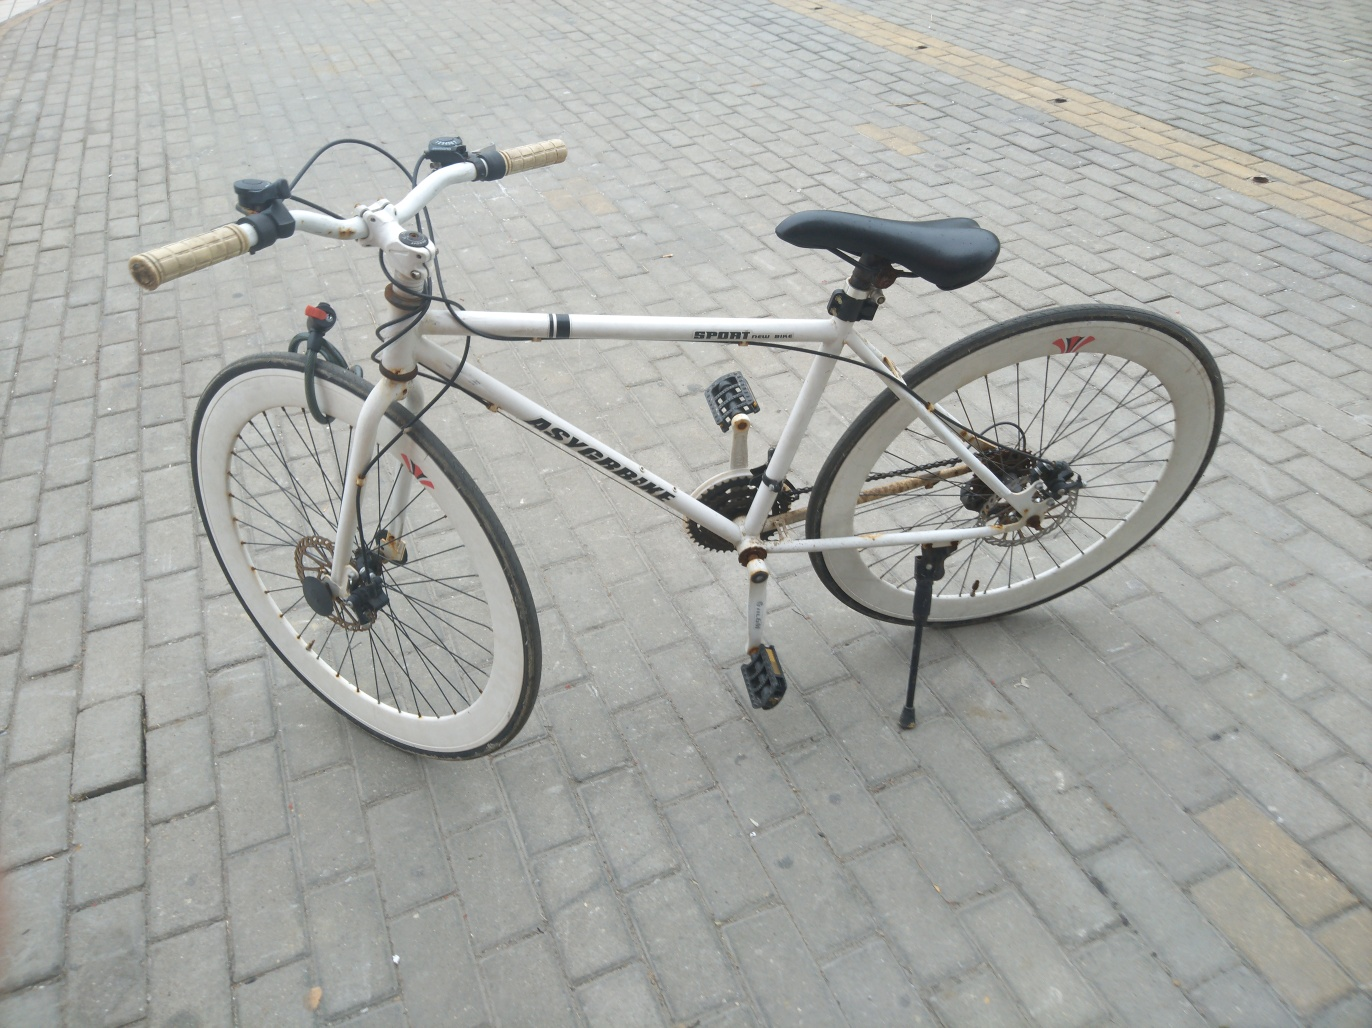What can you tell me about the setting of this image? The bicycle is parked on a paved area with uniformly shaped paving stones, suggesting a well-maintained urban or public space. The lack of traffic markings or nearby vehicles might imply that the location is a pedestrian area or a designated bike park. 